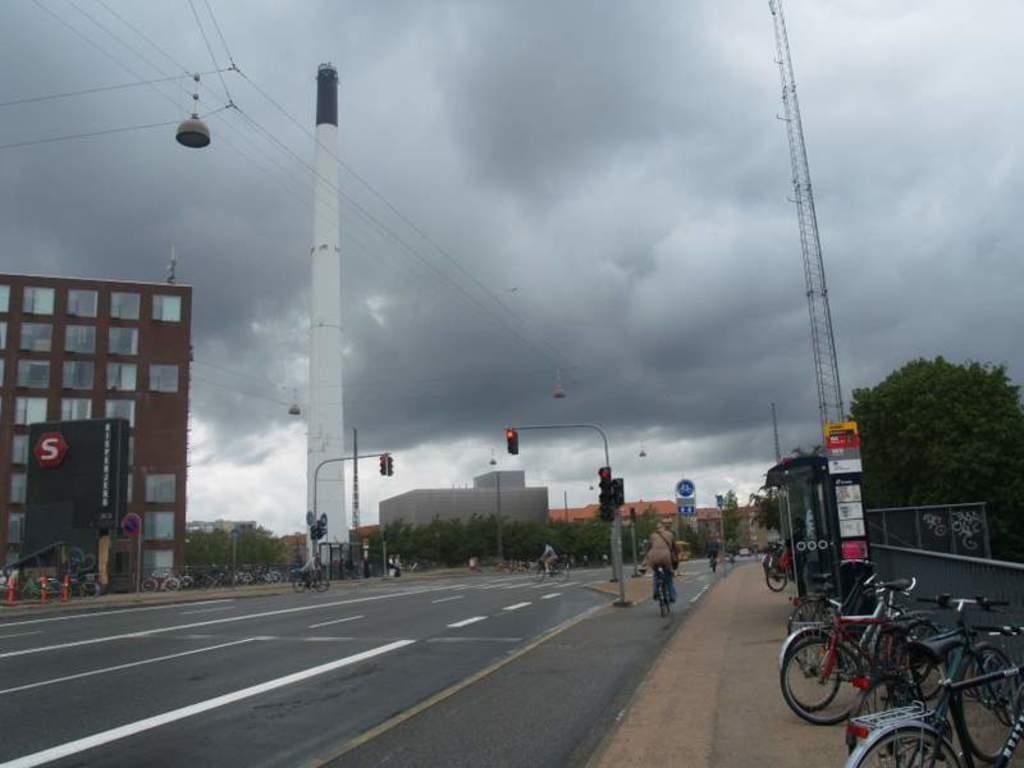Could you give a brief overview of what you see in this image? There is a road. There are traffic lights with poles. On the right side there are cycles on the sidewalk. Also there is a wall and tower. Near to that there is a tree. On the left side there is a building. In front of that there are many cycles. Also there is a tower. In the background there are many trees, buildings and sky. There are sign boards. And there are many people riding cycles. 